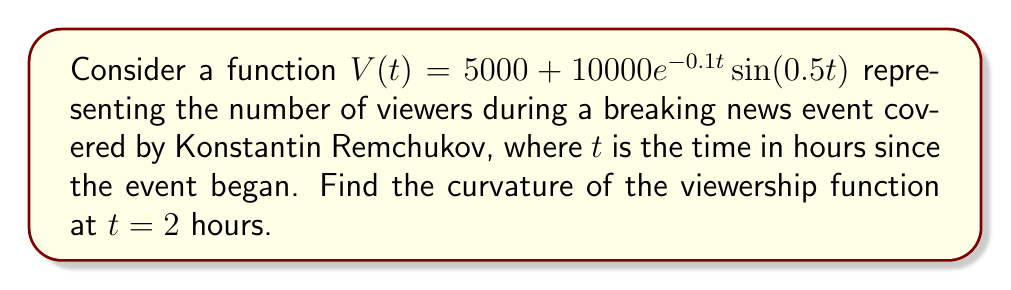Give your solution to this math problem. To find the curvature of the viewership function, we'll use the formula for curvature:

$$\kappa(t) = \frac{|V''(t)|}{(1 + (V'(t))^2)^{3/2}}$$

Step 1: Calculate $V'(t)$
$$V'(t) = 10000e^{-0.1t}(-0.1\sin(0.5t) + 0.5\cos(0.5t))$$

Step 2: Calculate $V''(t)$
$$V''(t) = 10000e^{-0.1t}(0.01\sin(0.5t) - 0.1\cos(0.5t) - 0.05\sin(0.5t) - 0.25\cos(0.5t))$$
$$= 10000e^{-0.1t}(-0.04\sin(0.5t) - 0.35\cos(0.5t))$$

Step 3: Evaluate $V'(2)$ and $V''(2)$
$$V'(2) = 10000e^{-0.2}(-0.1\sin(1) + 0.5\cos(1)) \approx 4093.8$$
$$V''(2) = 10000e^{-0.2}(-0.04\sin(1) - 0.35\cos(1)) \approx -2855.7$$

Step 4: Calculate the curvature at $t = 2$
$$\kappa(2) = \frac{|V''(2)|}{(1 + (V'(2))^2)^{3/2}}$$
$$= \frac{|-2855.7|}{(1 + 4093.8^2)^{3/2}}$$
$$\approx 4.185 \times 10^{-5}$$
Answer: $4.185 \times 10^{-5}$ 